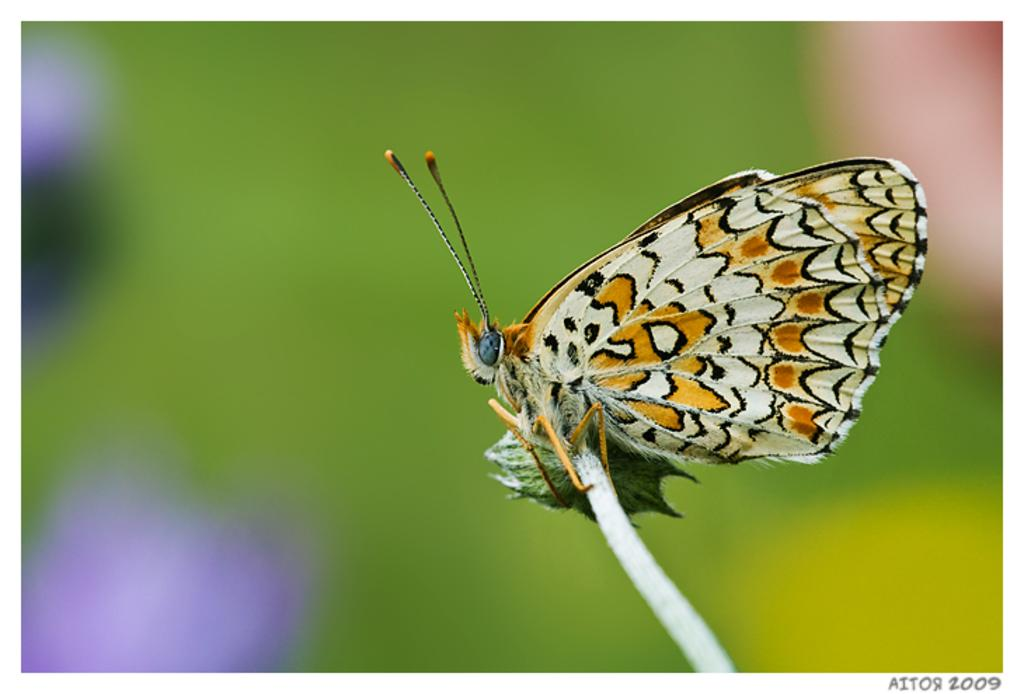What is the main subject of the image? There is a butterfly in the image. How is the butterfly positioned in the image? The butterfly is on a stick. Can you describe the background of the image? The background of the image is blurry. What type of shoe can be seen in the image? There is no shoe present in the image; it features a butterfly on a stick with a blurry background. 